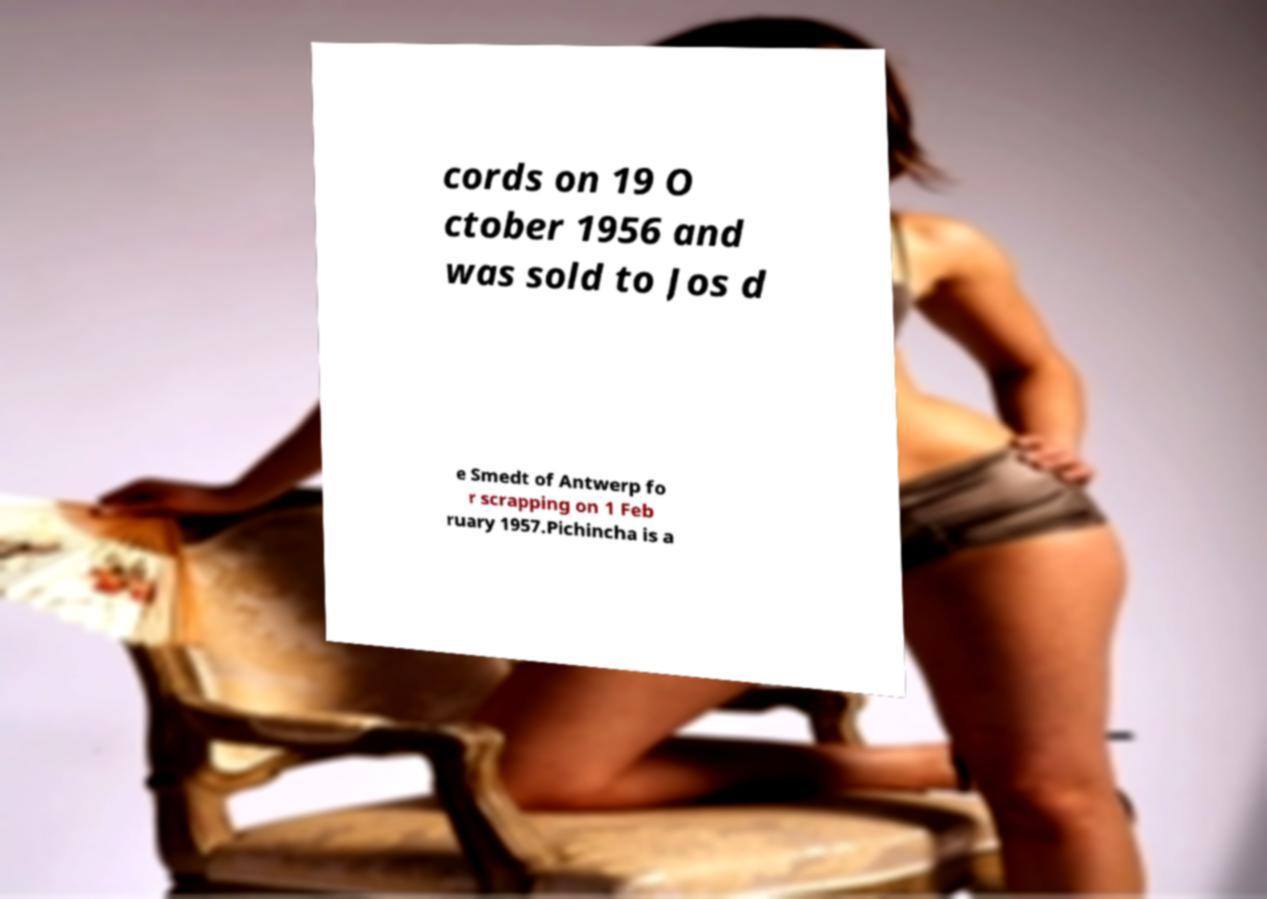What messages or text are displayed in this image? I need them in a readable, typed format. cords on 19 O ctober 1956 and was sold to Jos d e Smedt of Antwerp fo r scrapping on 1 Feb ruary 1957.Pichincha is a 